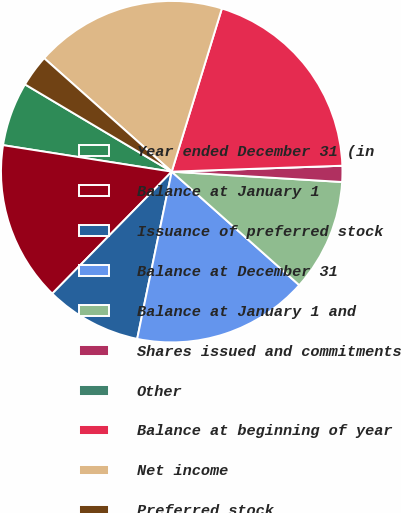<chart> <loc_0><loc_0><loc_500><loc_500><pie_chart><fcel>Year ended December 31 (in<fcel>Balance at January 1<fcel>Issuance of preferred stock<fcel>Balance at December 31<fcel>Balance at January 1 and<fcel>Shares issued and commitments<fcel>Other<fcel>Balance at beginning of year<fcel>Net income<fcel>Preferred stock<nl><fcel>6.06%<fcel>15.15%<fcel>9.09%<fcel>16.67%<fcel>10.61%<fcel>1.52%<fcel>0.0%<fcel>19.7%<fcel>18.18%<fcel>3.03%<nl></chart> 